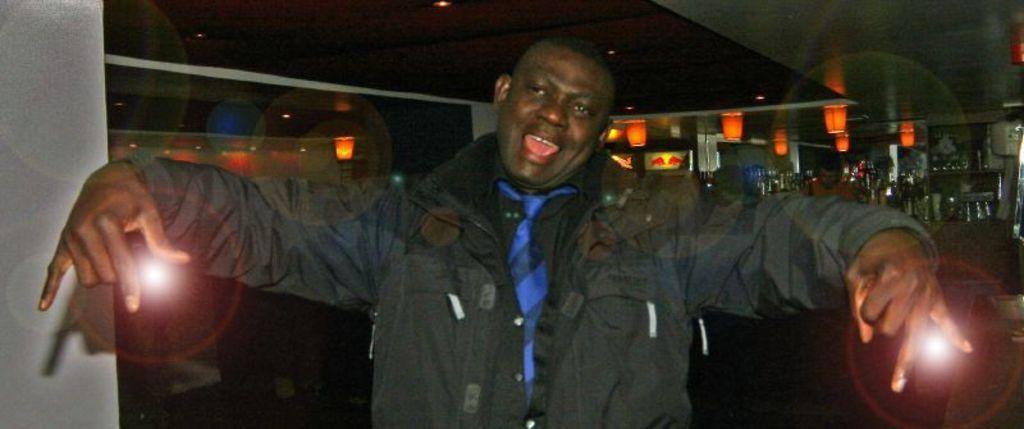Can you describe this image briefly? In this image in the front there is a person standing and smiling. In the background there are bottles and glasses and there are lights and there is a person. 